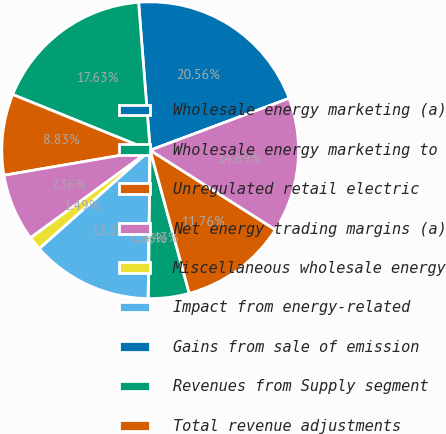<chart> <loc_0><loc_0><loc_500><loc_500><pie_chart><fcel>Wholesale energy marketing (a)<fcel>Wholesale energy marketing to<fcel>Unregulated retail electric<fcel>Net energy trading margins (a)<fcel>Miscellaneous wholesale energy<fcel>Impact from energy-related<fcel>Gains from sale of emission<fcel>Revenues from Supply segment<fcel>Total revenue adjustments<fcel>Fuel (a)<nl><fcel>20.56%<fcel>17.63%<fcel>8.83%<fcel>7.36%<fcel>1.49%<fcel>13.23%<fcel>0.03%<fcel>4.43%<fcel>11.76%<fcel>14.69%<nl></chart> 